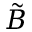<formula> <loc_0><loc_0><loc_500><loc_500>\tilde { B }</formula> 